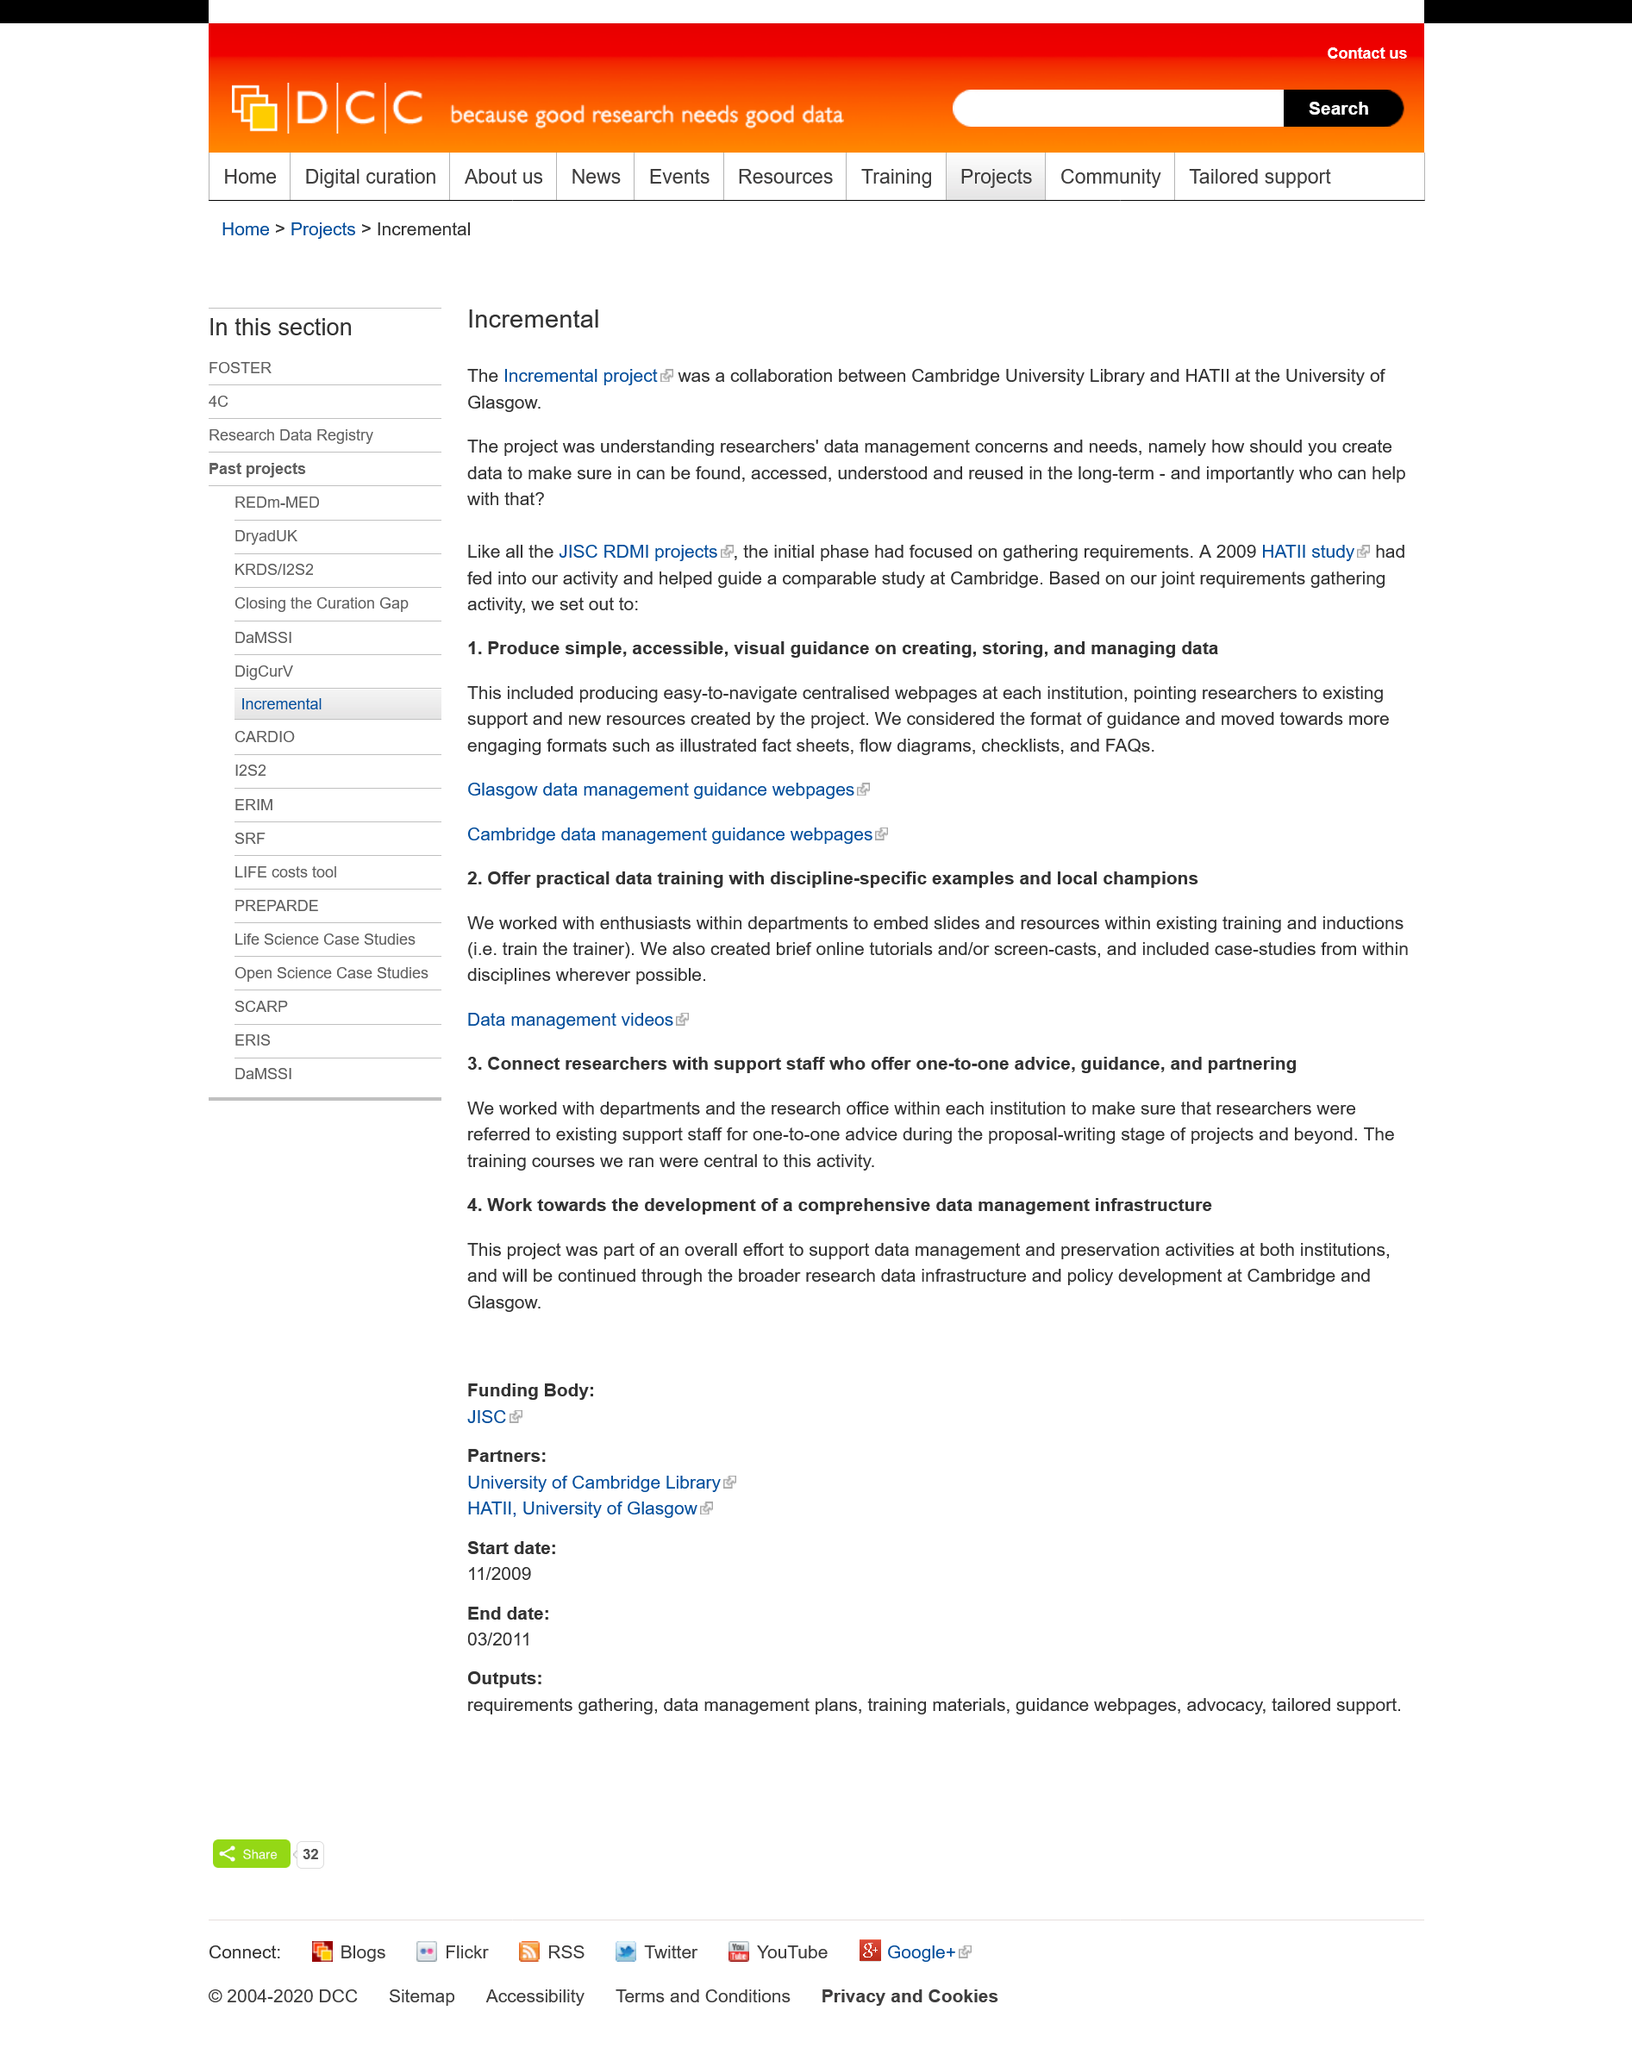Indicate a few pertinent items in this graphic. The Incremental Project was collaboratively undertaken by Cambridge University Library and HaTII at the University of Glasgow. The purpose of this project was to gain insight into the data management concerns and needs of researchers. The 2009 HATII study had contributed to the activity and had played a crucial role in guiding a similar study at Cambridge. The initial phase of the Incremental project was focused on gathering requirements. 